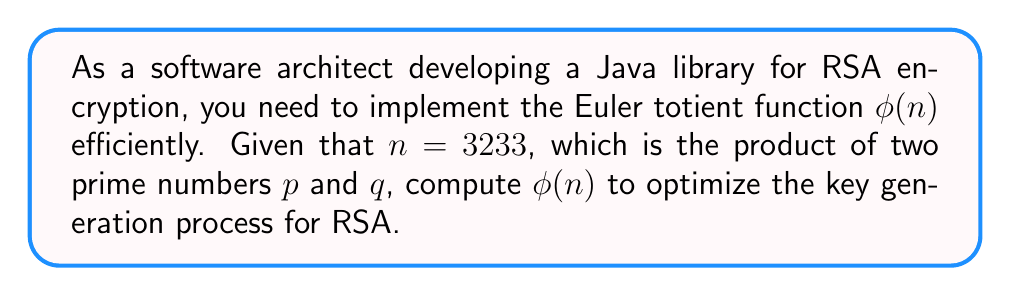Show me your answer to this math problem. To compute the Euler totient function $\phi(n)$ for $n = 3233$, we'll follow these steps:

1. First, we need to find the prime factors of $n$. Since we're told $n$ is the product of two primes $p$ and $q$, we can find these by trial division:
   $3233 = 61 \times 53$

2. Now that we have $p = 61$ and $q = 53$, we can use the property of the Euler totient function for prime numbers:
   For a prime number $a$, $\phi(a) = a - 1$

3. For a product of two distinct primes $p$ and $q$, the Euler totient function is given by:
   $$\phi(n) = \phi(p) \times \phi(q) = (p-1) \times (q-1)$$

4. Let's calculate:
   $$\phi(3233) = \phi(61) \times \phi(53) = (61-1) \times (53-1) = 60 \times 52$$

5. Multiply:
   $$\phi(3233) = 60 \times 52 = 3120$$

Therefore, the value of the Euler totient function for $n = 3233$ is 3120.

In Java, you could implement this efficiently using:

```java
public static int phi(int n) {
    int result = n;
    for (int i = 2; i * i <= n; i++) {
        if (n % i == 0) {
            while (n % i == 0) {
                n /= i;
            }
            result -= result / i;
        }
    }
    if (n > 1) {
        result -= result / n;
    }
    return result;
}
```

This implementation is more efficient for larger numbers and doesn't require prior knowledge of the prime factors.
Answer: $\phi(3233) = 3120$ 